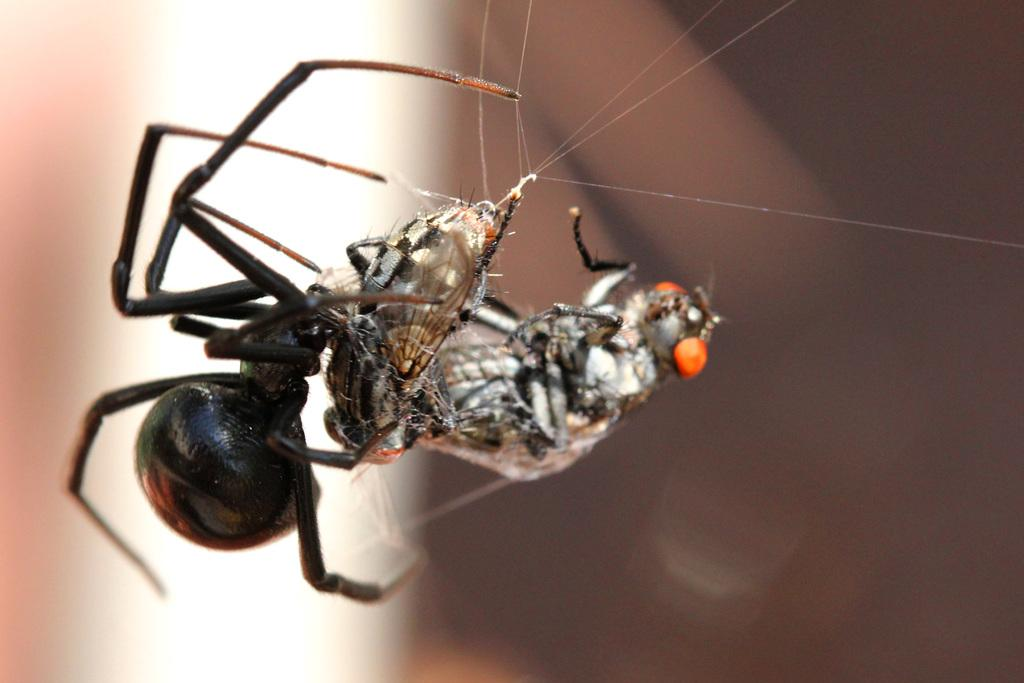How many spiders can be seen in the image? There are two spiders in the image. What do the spiders appear to be doing in the image? The spiders are on a web in the image. Can you describe the background of the image? The background of the image is blurred. What type of dinner is being served in the image? There is no dinner present in the image; it features two spiders on a web. What thrilling activity is taking place in the image? There is no thrilling activity present in the image; it features two spiders on a web. 